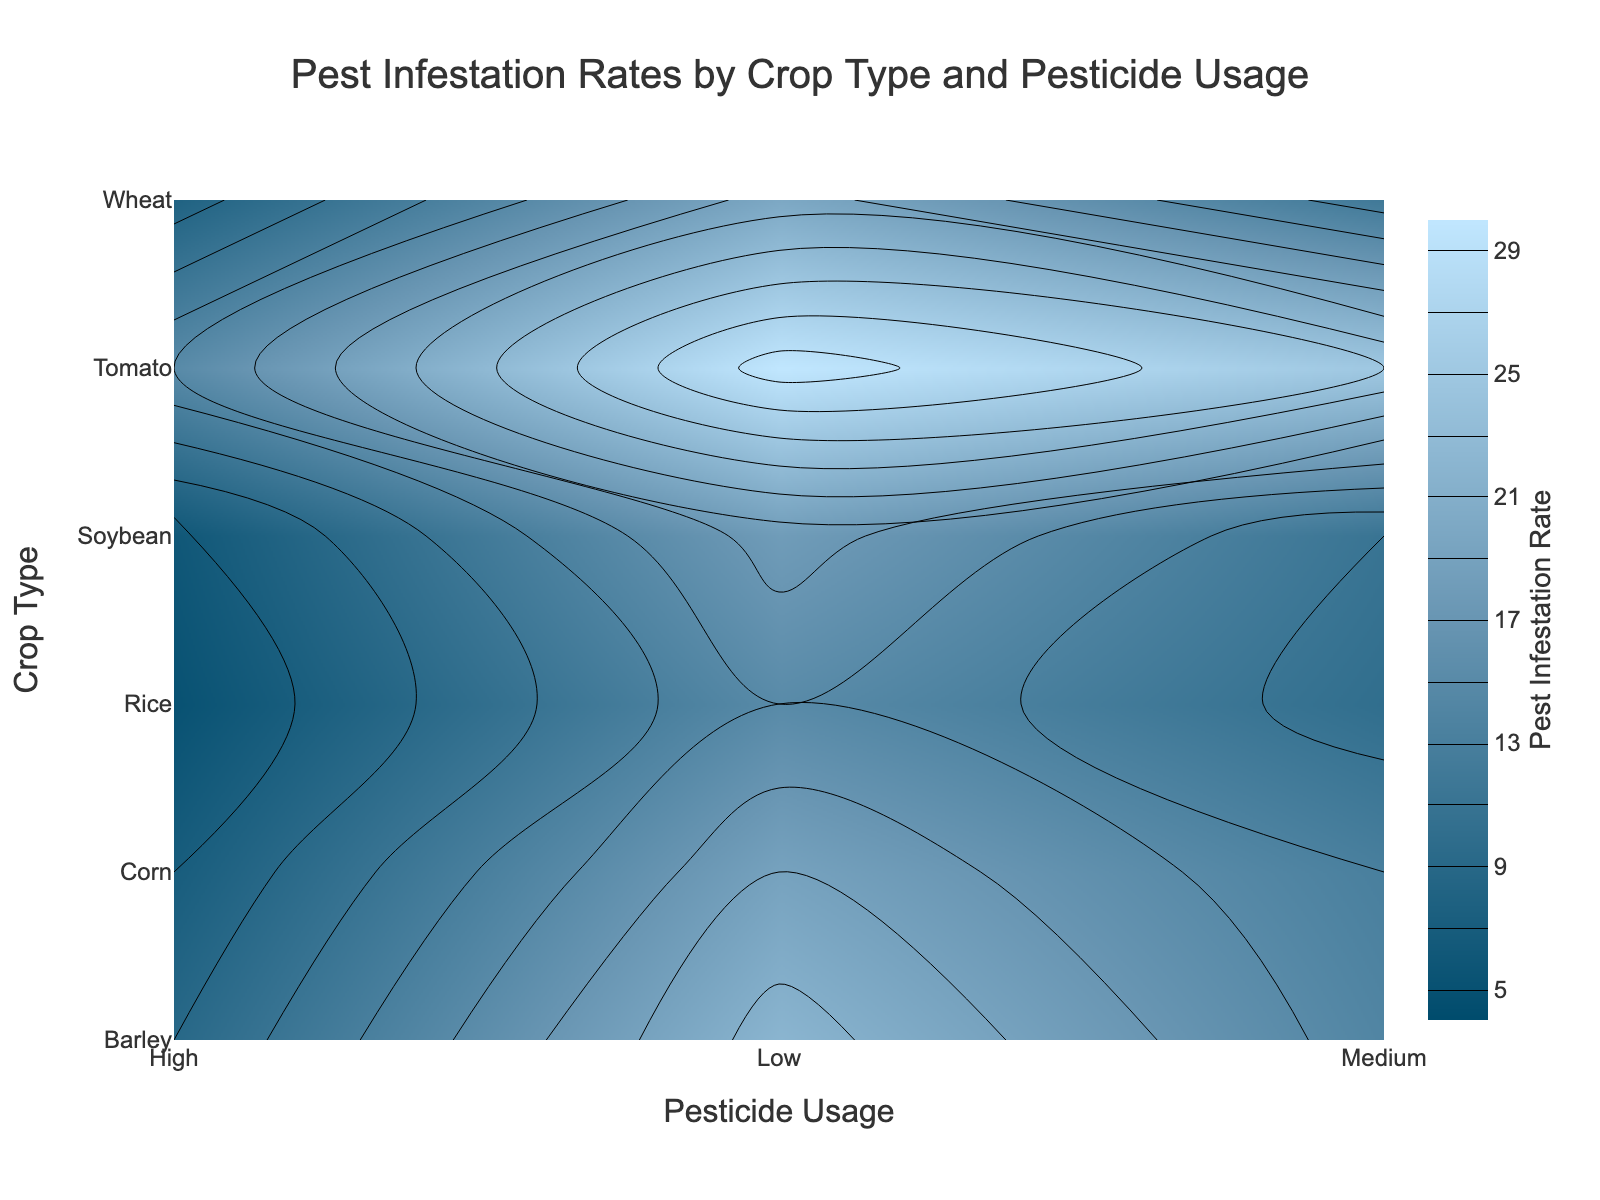What is the pest infestation rate for Rice with high pesticide usage? Locate the 'Rice' row on the Y-axis and the 'High' column on the X-axis. The pest infestation rate at this intersection is 5%.
Answer: 5% What is the color scale used in the contour plot? The color scale ranges from a deep blue to a light blue.
Answer: Deep blue to light blue Which crop type has the highest pest infestation rate when pesticide usage is low? Locate the 'Low' column on the X-axis and identify the highest value among the crop types. Tomato has the highest infestation rate of 30%.
Answer: Tomato How does the pest infestation rate change for Wheat as pesticide usage increases from Low to High? For Wheat, trace from 'Low' to 'High' on the X-axis to see how the values change. The infestation rate decreases from 20% (Low) to 8% (High).
Answer: Decreases Which crop type shows the most significant reduction in pest infestation rates when comparing low to medium pesticide usage? Compare the difference between Low and Medium pesticide usage for each crop type. Tomato shows the most significant reduction from 30% to 25%, a decrease of 5%.
Answer: Tomato Is the pest infestation rate for Soybean with medium pesticide usage greater than the pest infestation rate for Barley with high pesticide usage? Compare the rate for Soybean at Medium (11%) with Barley at High (9%). The rate for Soybean is higher.
Answer: Yes What’s the average pest infestation rate for all crop types when pesticide usage is high? Sum the values for all crops under 'High' pesticide usage and divide by the number of crops. (5 + 8 + 6 + 9 + 7 + 15) / 6 = 50 / 6 = 8.33%.
Answer: 8.33% How does pesticide usage affect pest infestation for Corn? Look at the pest infestation rates for Corn across Low, Medium, and High pesticide usage: 19% (Low), 13% (Medium), 7% (High). The rate consistently decreases as pesticide usage increases.
Answer: Decreases Which crop has a pest infestation rate of 14% and what is the pesticide usage level? Locate the value 14% on the plot and identify the corresponding crop type and pesticide usage. Barley at Medium pesticide usage has a rate of 14%.
Answer: Barley, Medium What is the overall trend shown in the contour plot regarding pesticide usage and pest infestation rates? Generally, as pesticide usage goes from Low to High, pest infestation rates decrease for all crop types. This is observed in the contour lines moving from higher values to lower values consistently across the X-axis for each Y-axis category.
Answer: Decreases 